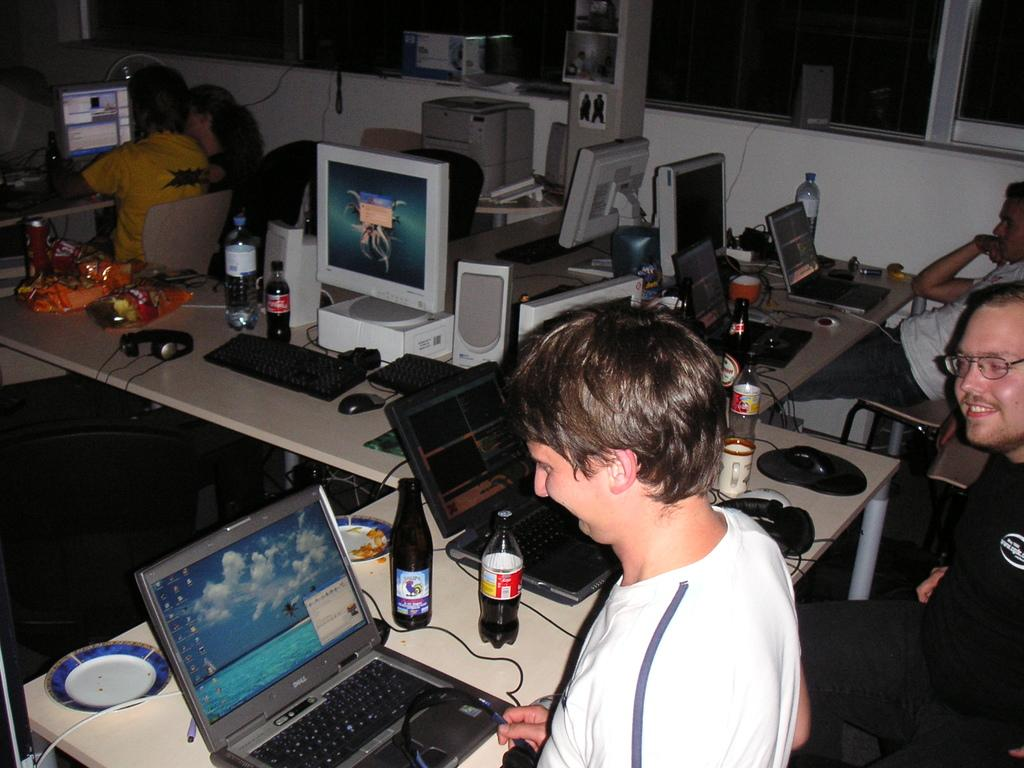Who or what can be seen in the image? There are people in the image. What objects are present on the table in the image? There are computers on a table in the image. What type of dock can be seen in the image? There is no dock present in the image. Can you describe the airport in the image? There is no airport present in the image. 